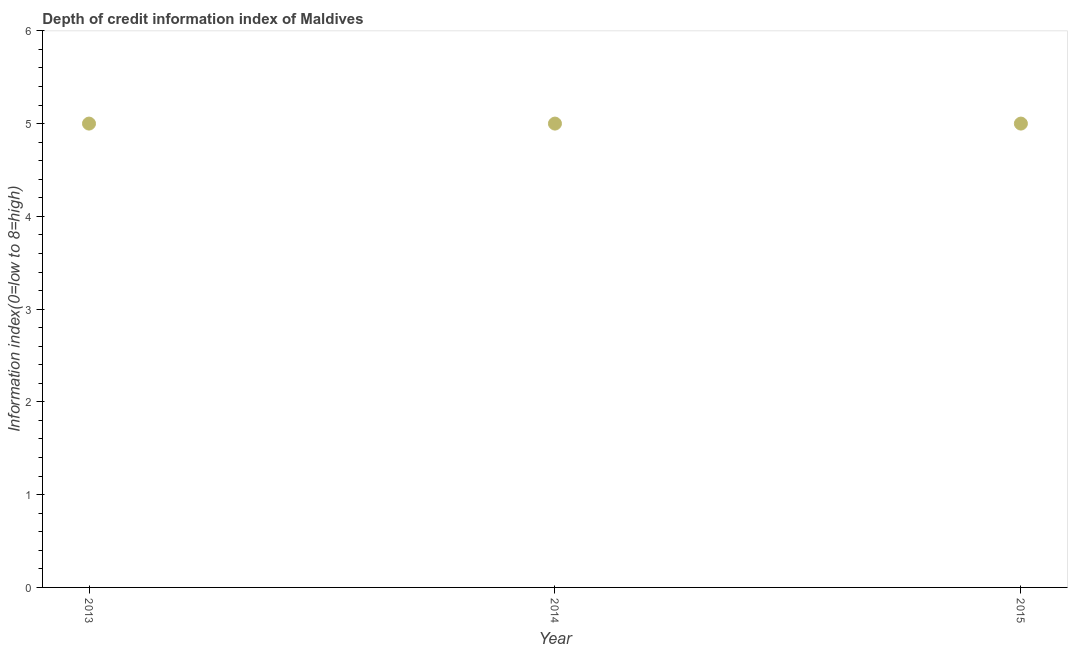What is the depth of credit information index in 2013?
Your answer should be compact. 5. Across all years, what is the maximum depth of credit information index?
Provide a short and direct response. 5. Across all years, what is the minimum depth of credit information index?
Your answer should be very brief. 5. In which year was the depth of credit information index minimum?
Give a very brief answer. 2013. What is the sum of the depth of credit information index?
Offer a terse response. 15. Do a majority of the years between 2015 and 2014 (inclusive) have depth of credit information index greater than 4.4 ?
Your answer should be very brief. No. Is the depth of credit information index in 2013 less than that in 2014?
Make the answer very short. No. Is the sum of the depth of credit information index in 2013 and 2014 greater than the maximum depth of credit information index across all years?
Your response must be concise. Yes. In how many years, is the depth of credit information index greater than the average depth of credit information index taken over all years?
Ensure brevity in your answer.  0. Does the depth of credit information index monotonically increase over the years?
Offer a very short reply. No. How many dotlines are there?
Provide a succinct answer. 1. Are the values on the major ticks of Y-axis written in scientific E-notation?
Ensure brevity in your answer.  No. Does the graph contain any zero values?
Your response must be concise. No. Does the graph contain grids?
Keep it short and to the point. No. What is the title of the graph?
Your response must be concise. Depth of credit information index of Maldives. What is the label or title of the Y-axis?
Make the answer very short. Information index(0=low to 8=high). What is the Information index(0=low to 8=high) in 2014?
Offer a very short reply. 5. What is the Information index(0=low to 8=high) in 2015?
Your response must be concise. 5. What is the difference between the Information index(0=low to 8=high) in 2013 and 2014?
Give a very brief answer. 0. 